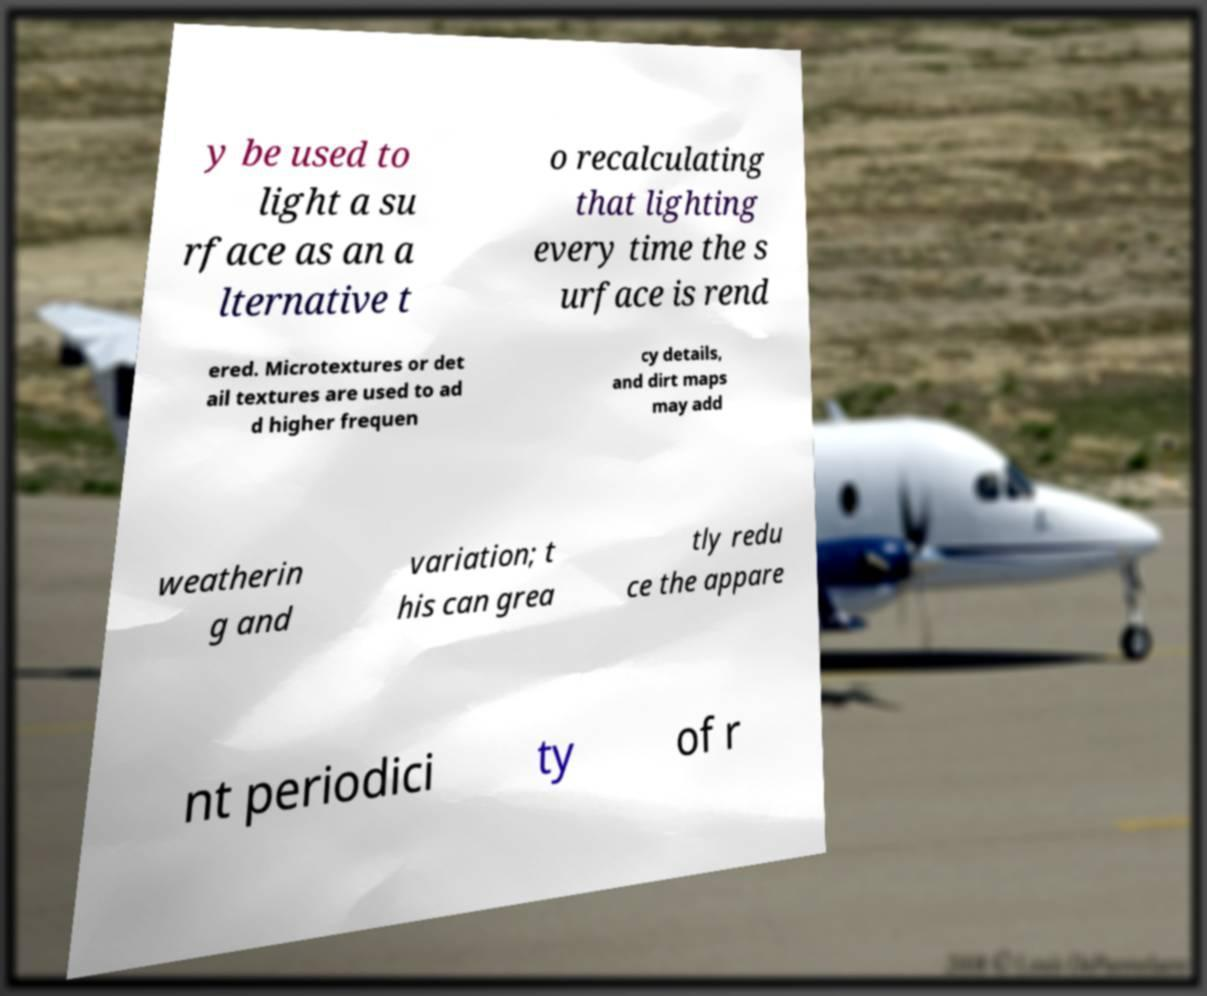For documentation purposes, I need the text within this image transcribed. Could you provide that? y be used to light a su rface as an a lternative t o recalculating that lighting every time the s urface is rend ered. Microtextures or det ail textures are used to ad d higher frequen cy details, and dirt maps may add weatherin g and variation; t his can grea tly redu ce the appare nt periodici ty of r 